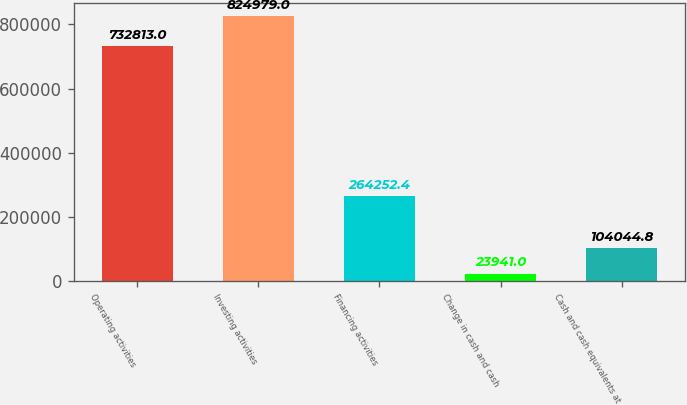Convert chart to OTSL. <chart><loc_0><loc_0><loc_500><loc_500><bar_chart><fcel>Operating activities<fcel>Investing activities<fcel>Financing activities<fcel>Change in cash and cash<fcel>Cash and cash equivalents at<nl><fcel>732813<fcel>824979<fcel>264252<fcel>23941<fcel>104045<nl></chart> 